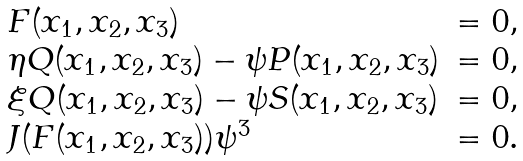<formula> <loc_0><loc_0><loc_500><loc_500>\begin{array} { l l l } F ( x _ { 1 } , x _ { 2 } , x _ { 3 } ) & = 0 , \\ \eta Q ( x _ { 1 } , x _ { 2 } , x _ { 3 } ) - \psi P ( x _ { 1 } , x _ { 2 } , x _ { 3 } ) & = 0 , \\ \xi Q ( x _ { 1 } , x _ { 2 } , x _ { 3 } ) - \psi S ( x _ { 1 } , x _ { 2 } , x _ { 3 } ) & = 0 , \\ J ( F ( x _ { 1 } , x _ { 2 } , x _ { 3 } ) ) \psi ^ { 3 } & = 0 . \end{array}</formula> 